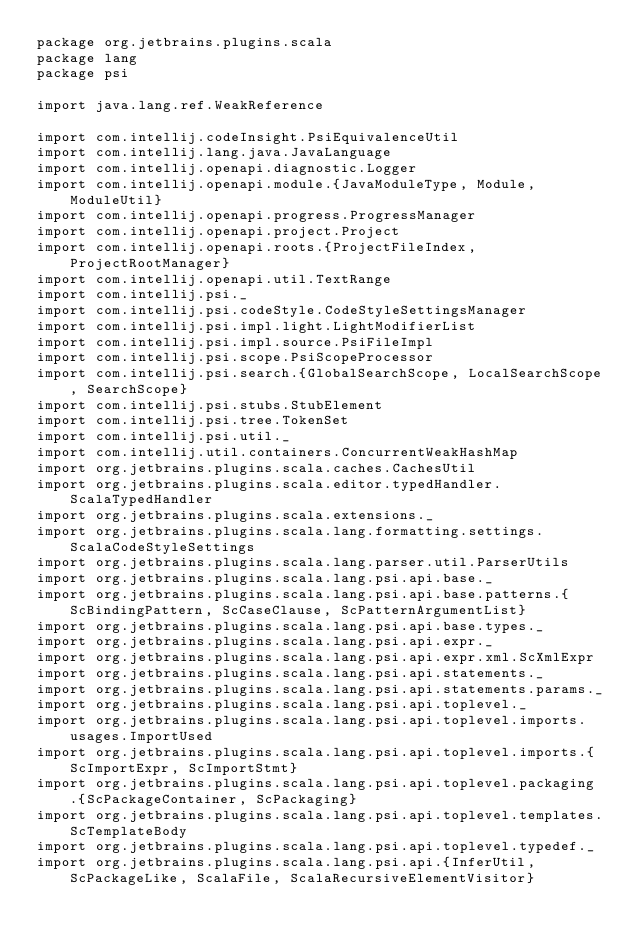<code> <loc_0><loc_0><loc_500><loc_500><_Scala_>package org.jetbrains.plugins.scala
package lang
package psi

import java.lang.ref.WeakReference

import com.intellij.codeInsight.PsiEquivalenceUtil
import com.intellij.lang.java.JavaLanguage
import com.intellij.openapi.diagnostic.Logger
import com.intellij.openapi.module.{JavaModuleType, Module, ModuleUtil}
import com.intellij.openapi.progress.ProgressManager
import com.intellij.openapi.project.Project
import com.intellij.openapi.roots.{ProjectFileIndex, ProjectRootManager}
import com.intellij.openapi.util.TextRange
import com.intellij.psi._
import com.intellij.psi.codeStyle.CodeStyleSettingsManager
import com.intellij.psi.impl.light.LightModifierList
import com.intellij.psi.impl.source.PsiFileImpl
import com.intellij.psi.scope.PsiScopeProcessor
import com.intellij.psi.search.{GlobalSearchScope, LocalSearchScope, SearchScope}
import com.intellij.psi.stubs.StubElement
import com.intellij.psi.tree.TokenSet
import com.intellij.psi.util._
import com.intellij.util.containers.ConcurrentWeakHashMap
import org.jetbrains.plugins.scala.caches.CachesUtil
import org.jetbrains.plugins.scala.editor.typedHandler.ScalaTypedHandler
import org.jetbrains.plugins.scala.extensions._
import org.jetbrains.plugins.scala.lang.formatting.settings.ScalaCodeStyleSettings
import org.jetbrains.plugins.scala.lang.parser.util.ParserUtils
import org.jetbrains.plugins.scala.lang.psi.api.base._
import org.jetbrains.plugins.scala.lang.psi.api.base.patterns.{ScBindingPattern, ScCaseClause, ScPatternArgumentList}
import org.jetbrains.plugins.scala.lang.psi.api.base.types._
import org.jetbrains.plugins.scala.lang.psi.api.expr._
import org.jetbrains.plugins.scala.lang.psi.api.expr.xml.ScXmlExpr
import org.jetbrains.plugins.scala.lang.psi.api.statements._
import org.jetbrains.plugins.scala.lang.psi.api.statements.params._
import org.jetbrains.plugins.scala.lang.psi.api.toplevel._
import org.jetbrains.plugins.scala.lang.psi.api.toplevel.imports.usages.ImportUsed
import org.jetbrains.plugins.scala.lang.psi.api.toplevel.imports.{ScImportExpr, ScImportStmt}
import org.jetbrains.plugins.scala.lang.psi.api.toplevel.packaging.{ScPackageContainer, ScPackaging}
import org.jetbrains.plugins.scala.lang.psi.api.toplevel.templates.ScTemplateBody
import org.jetbrains.plugins.scala.lang.psi.api.toplevel.typedef._
import org.jetbrains.plugins.scala.lang.psi.api.{InferUtil, ScPackageLike, ScalaFile, ScalaRecursiveElementVisitor}</code> 